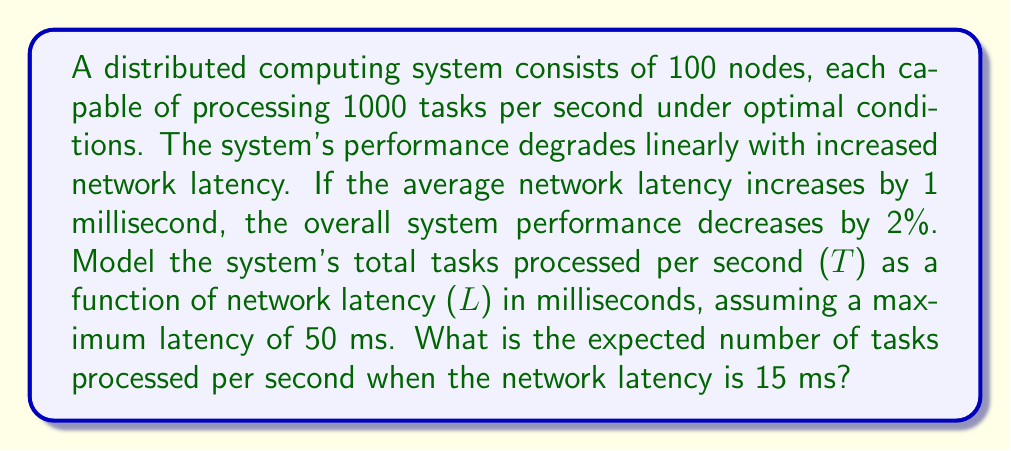Show me your answer to this math problem. 1. First, let's define the function for the system's performance:
   Let $T(L)$ be the total tasks processed per second as a function of latency $L$.

2. Under optimal conditions (L = 0 ms):
   $T(0) = 100 \text{ nodes} \times 1000 \text{ tasks/s} = 100,000 \text{ tasks/s}$

3. The performance decreases linearly with latency, at a rate of 2% per 1 ms increase:
   Rate of decrease: $r = 0.02 \text{ per ms}$

4. We can model this as a linear function:
   $T(L) = T(0) \times (1 - rL)$
   $T(L) = 100,000 \times (1 - 0.02L)$

5. Simplify the equation:
   $T(L) = 100,000 - 2,000L$

6. To find $T(15)$, we substitute $L = 15$ into our equation:
   $T(15) = 100,000 - 2,000 \times 15$
   $T(15) = 100,000 - 30,000$
   $T(15) = 70,000$

Therefore, when the network latency is 15 ms, the expected number of tasks processed per second is 70,000.
Answer: 70,000 tasks/s 